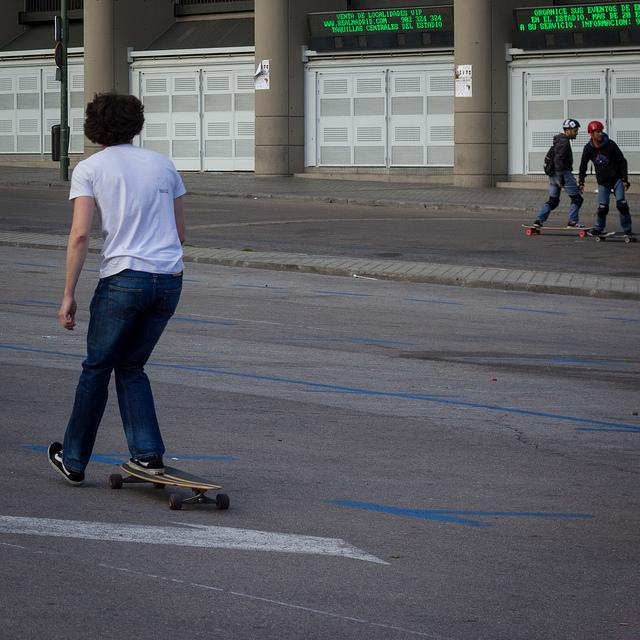What style of skateboard is the man in the white shirt using? long board 